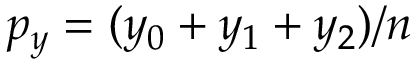<formula> <loc_0><loc_0><loc_500><loc_500>p _ { y } = ( y _ { 0 } + y _ { 1 } + y _ { 2 } ) / n</formula> 